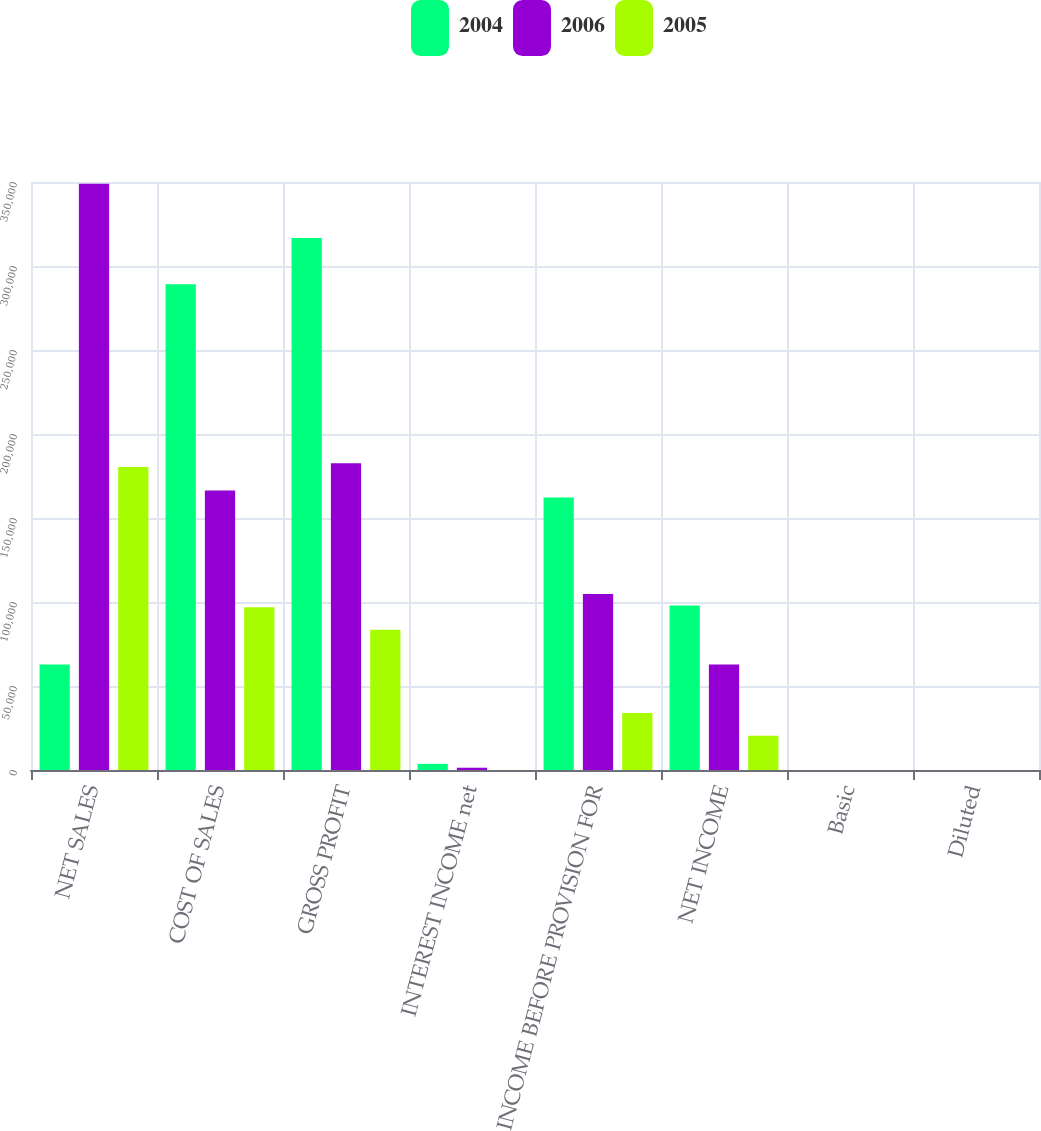Convert chart to OTSL. <chart><loc_0><loc_0><loc_500><loc_500><stacked_bar_chart><ecel><fcel>NET SALES<fcel>COST OF SALES<fcel>GROSS PROFIT<fcel>INTEREST INCOME net<fcel>INCOME BEFORE PROVISION FOR<fcel>NET INCOME<fcel>Basic<fcel>Diluted<nl><fcel>2004<fcel>62775<fcel>289180<fcel>316594<fcel>3660<fcel>162239<fcel>97949<fcel>1.09<fcel>0.99<nl><fcel>2006<fcel>348886<fcel>166343<fcel>182543<fcel>1351<fcel>104794<fcel>62775<fcel>0.71<fcel>0.65<nl><fcel>2005<fcel>180341<fcel>96875<fcel>83466<fcel>52<fcel>33938<fcel>20387<fcel>0.24<fcel>0.22<nl></chart> 